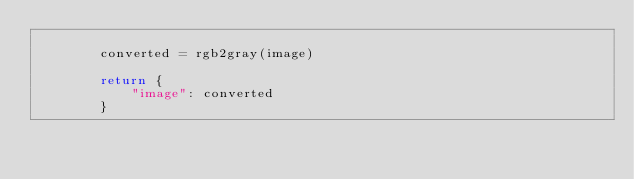<code> <loc_0><loc_0><loc_500><loc_500><_Python_>
        converted = rgb2gray(image)

        return {
            "image": converted
        }
</code> 